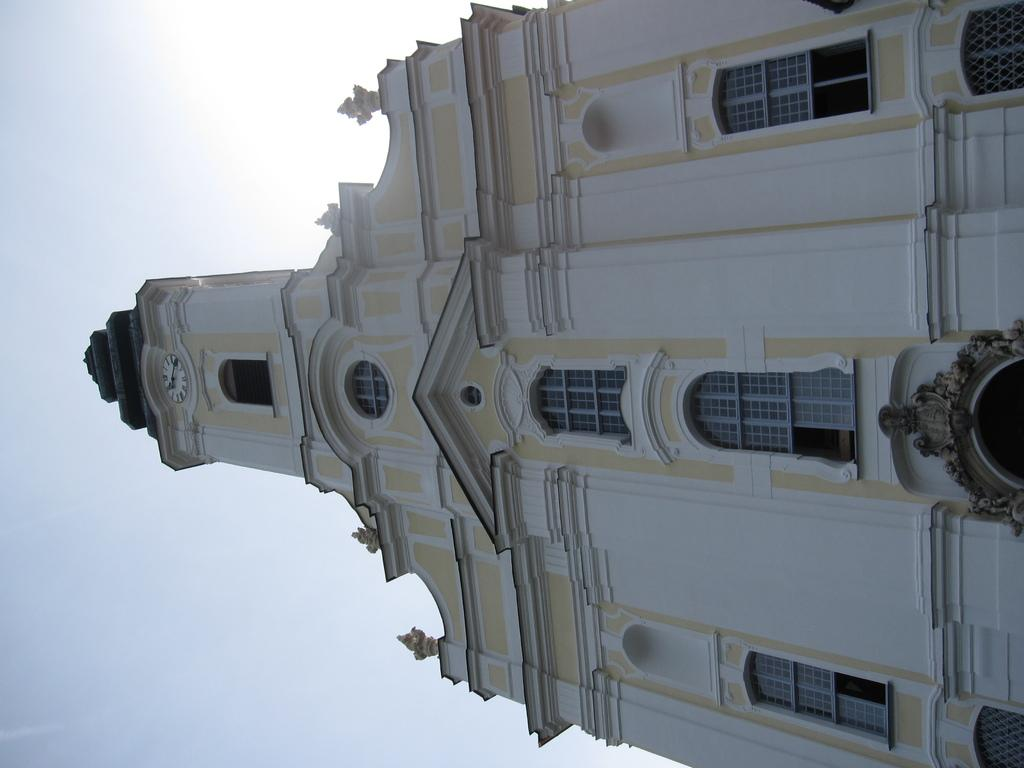What type of structure is in the image? There is a building in the image. What features can be seen on the building? The building has windows, arches, and a clock. What is visible in the background of the image? The sky is visible in the background of the image. Where is the mailbox located in the image? There is no mailbox present in the image. What type of chair can be seen in the image? There is no chair present in the image. 